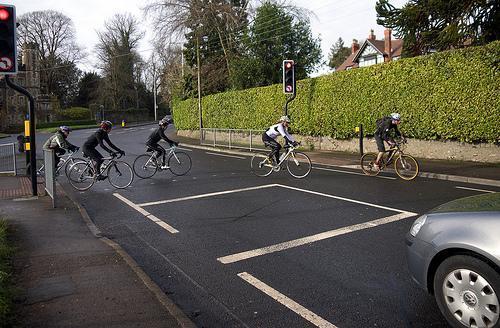How many bikers are in the picture?
Give a very brief answer. 5. How many bicyclists are there?
Give a very brief answer. 5. How many people are on bicycles?
Give a very brief answer. 5. How many of the car's wheels can we see?
Give a very brief answer. 1. 